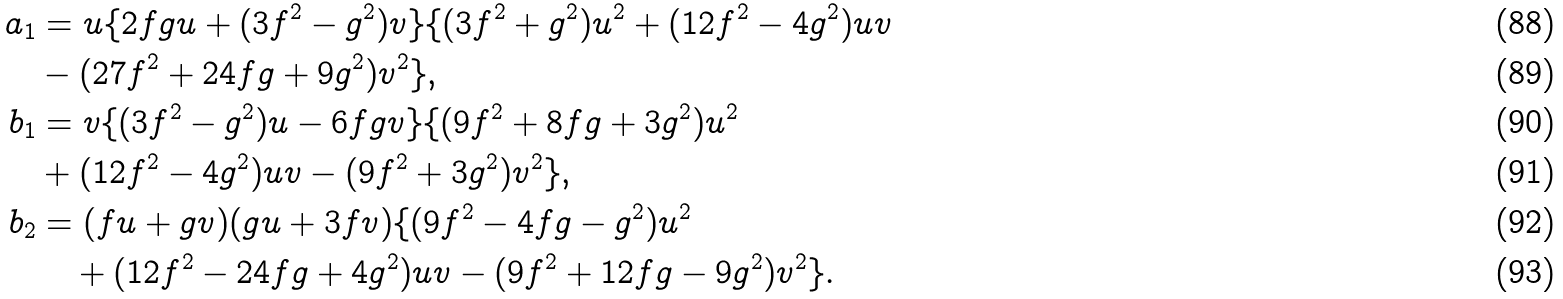<formula> <loc_0><loc_0><loc_500><loc_500>a _ { 1 } & = u \{ 2 f g u + ( 3 f ^ { 2 } - g ^ { 2 } ) v \} \{ ( 3 f ^ { 2 } + g ^ { 2 } ) u ^ { 2 } + ( 1 2 f ^ { 2 } - 4 g ^ { 2 } ) u v \\ & - ( 2 7 f ^ { 2 } + 2 4 f g + 9 g ^ { 2 } ) v ^ { 2 } \} , \\ b _ { 1 } & = v \{ ( 3 f ^ { 2 } - g ^ { 2 } ) u - 6 f g v \} \{ ( 9 f ^ { 2 } + 8 f g + 3 g ^ { 2 } ) u ^ { 2 } \\ & + ( 1 2 f ^ { 2 } - 4 g ^ { 2 } ) u v - ( 9 f ^ { 2 } + 3 g ^ { 2 } ) v ^ { 2 } \} , \\ b _ { 2 } & = ( f u + g v ) ( g u + 3 f v ) \{ ( 9 f ^ { 2 } - 4 f g - g ^ { 2 } ) u ^ { 2 } \\ & \quad + ( 1 2 f ^ { 2 } - 2 4 f g + 4 g ^ { 2 } ) u v - ( 9 f ^ { 2 } + 1 2 f g - 9 g ^ { 2 } ) v ^ { 2 } \} .</formula> 